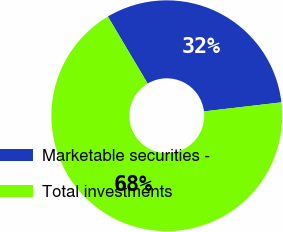Convert chart. <chart><loc_0><loc_0><loc_500><loc_500><pie_chart><fcel>Marketable securities -<fcel>Total investments<nl><fcel>31.68%<fcel>68.32%<nl></chart> 